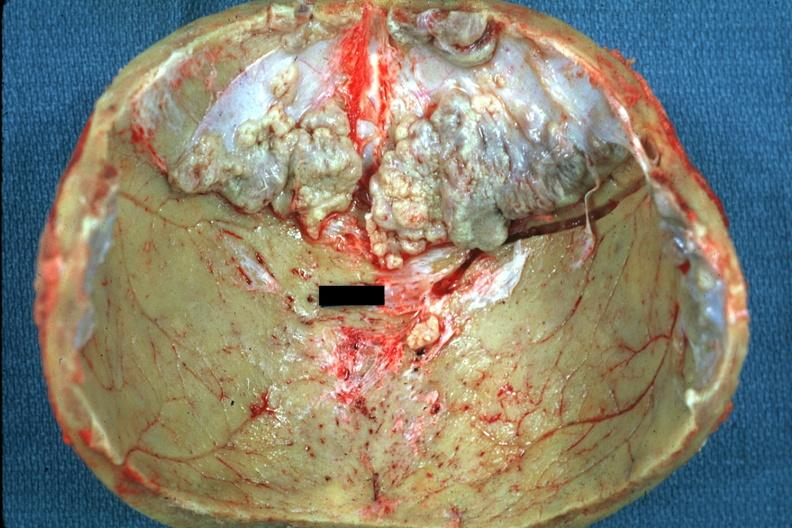s medial aspect present?
Answer the question using a single word or phrase. No 